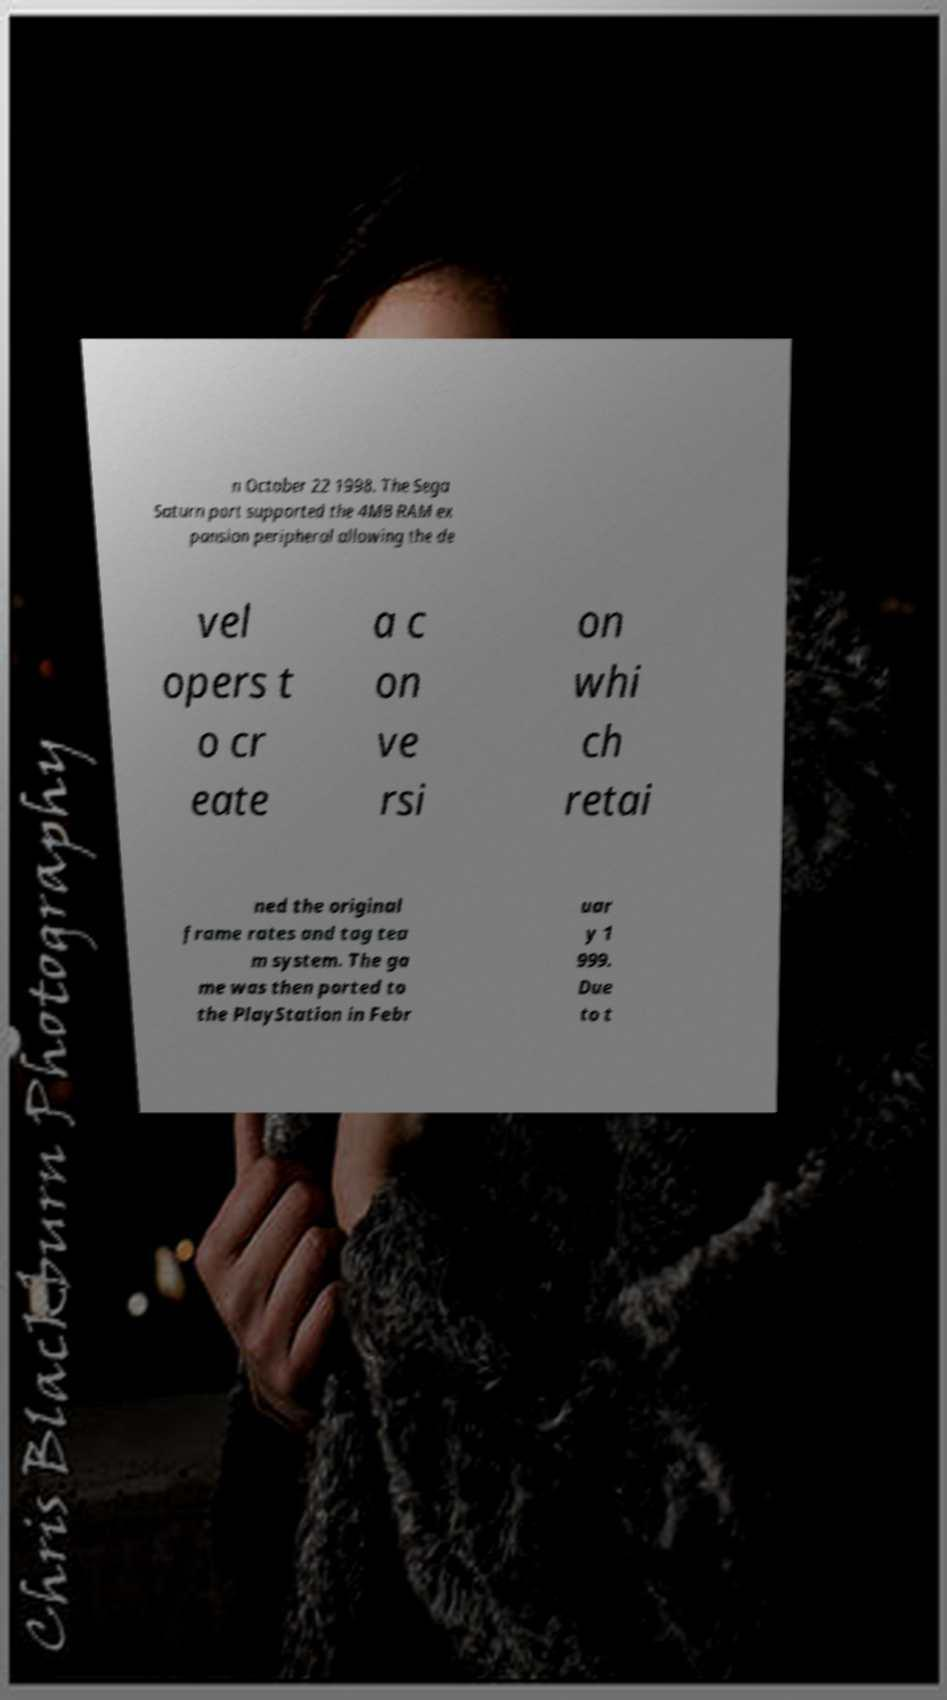Please identify and transcribe the text found in this image. n October 22 1998. The Sega Saturn port supported the 4MB RAM ex pansion peripheral allowing the de vel opers t o cr eate a c on ve rsi on whi ch retai ned the original frame rates and tag tea m system. The ga me was then ported to the PlayStation in Febr uar y 1 999. Due to t 